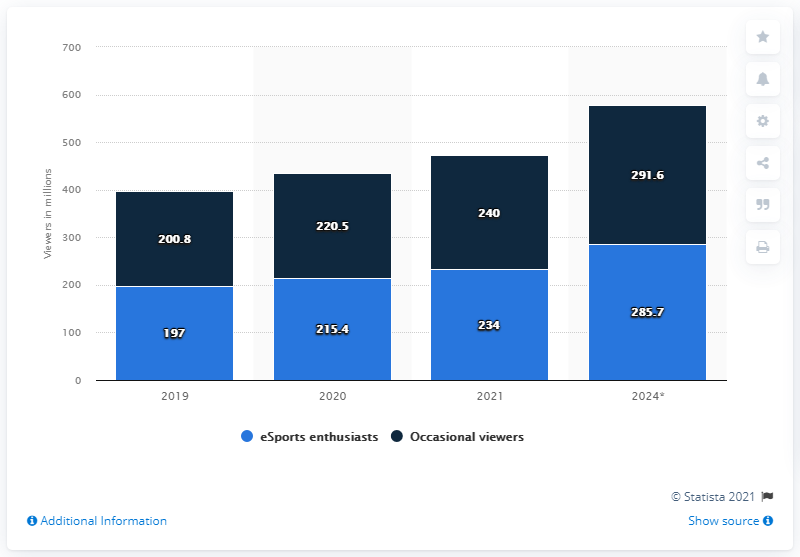Give some essential details in this illustration. By 2024, it is expected that a total of 291.6 people will be occasional viewers of eSports, marking a significant increase from current levels. The number of eSports enthusiasts is expected to reach 285.7 million by 2024. 